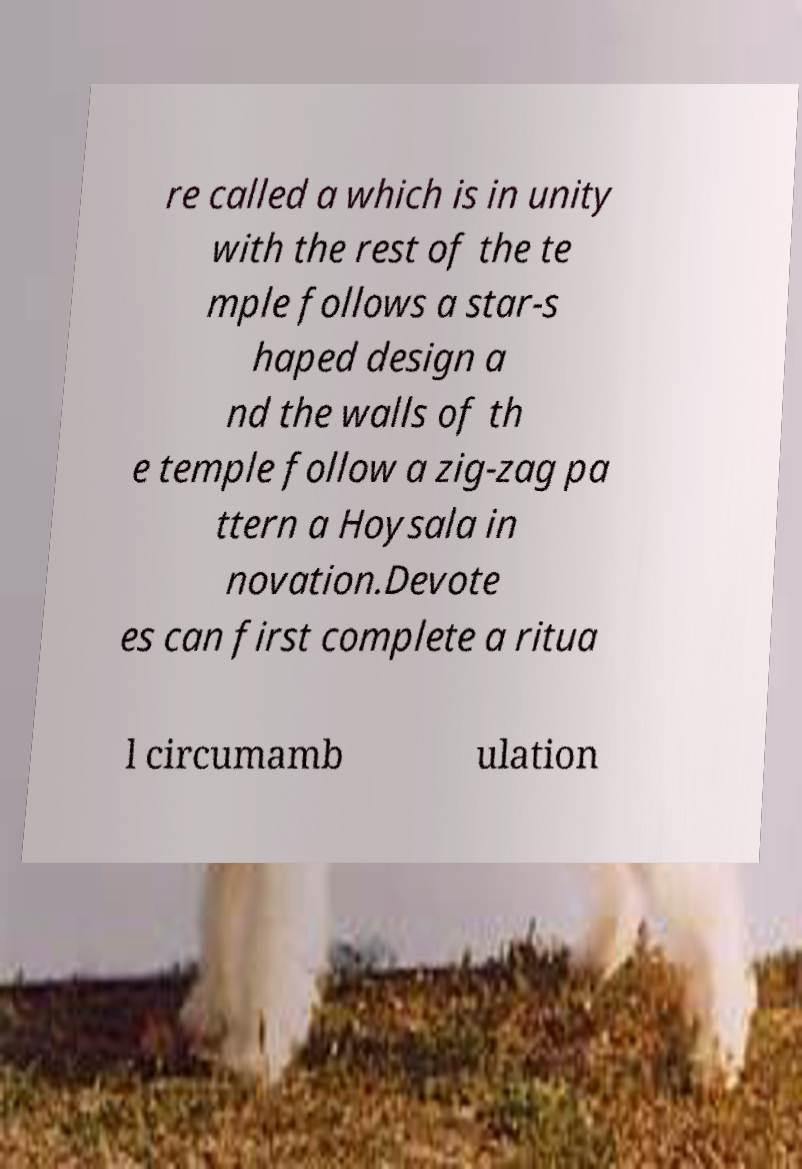Can you read and provide the text displayed in the image?This photo seems to have some interesting text. Can you extract and type it out for me? re called a which is in unity with the rest of the te mple follows a star-s haped design a nd the walls of th e temple follow a zig-zag pa ttern a Hoysala in novation.Devote es can first complete a ritua l circumamb ulation 